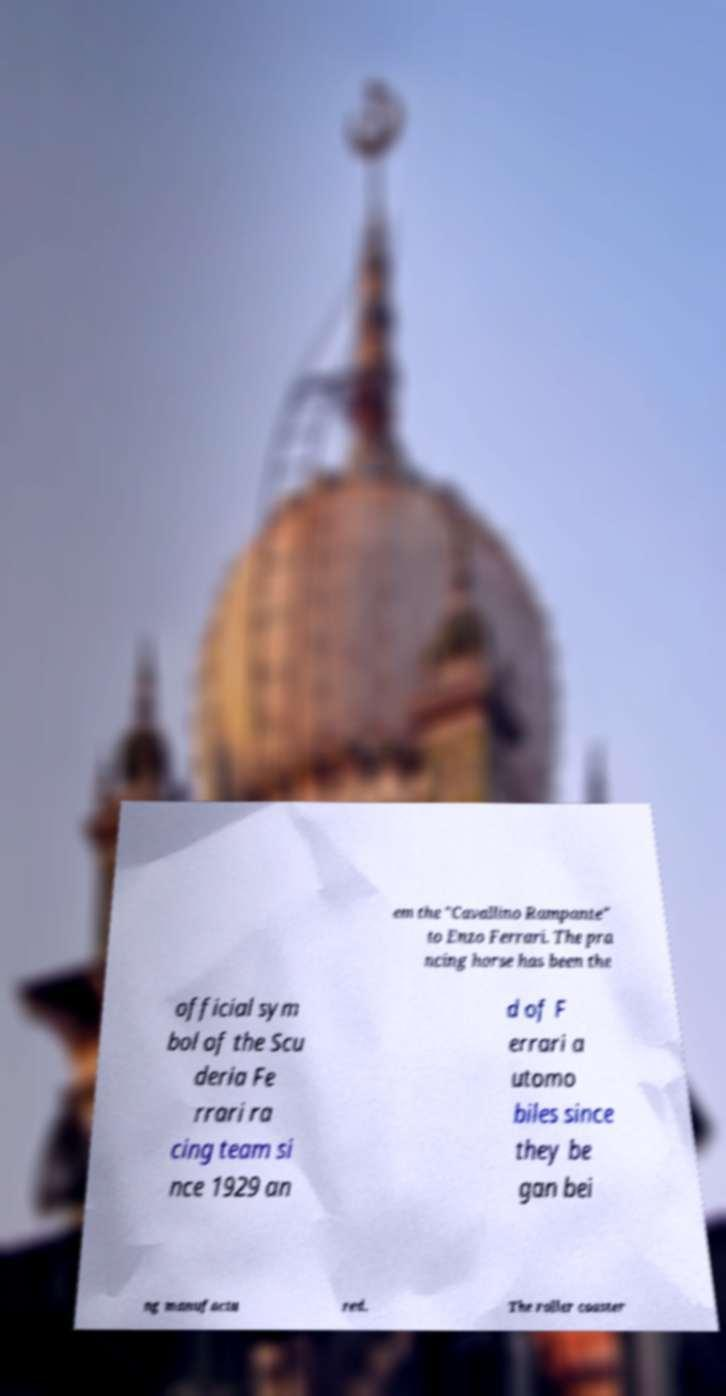Please read and relay the text visible in this image. What does it say? em the "Cavallino Rampante" to Enzo Ferrari. The pra ncing horse has been the official sym bol of the Scu deria Fe rrari ra cing team si nce 1929 an d of F errari a utomo biles since they be gan bei ng manufactu red. The roller coaster 